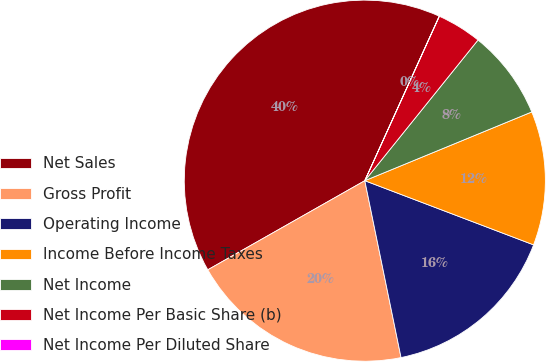<chart> <loc_0><loc_0><loc_500><loc_500><pie_chart><fcel>Net Sales<fcel>Gross Profit<fcel>Operating Income<fcel>Income Before Income Taxes<fcel>Net Income<fcel>Net Income Per Basic Share (b)<fcel>Net Income Per Diluted Share<nl><fcel>39.98%<fcel>20.0%<fcel>16.0%<fcel>12.0%<fcel>8.0%<fcel>4.01%<fcel>0.01%<nl></chart> 